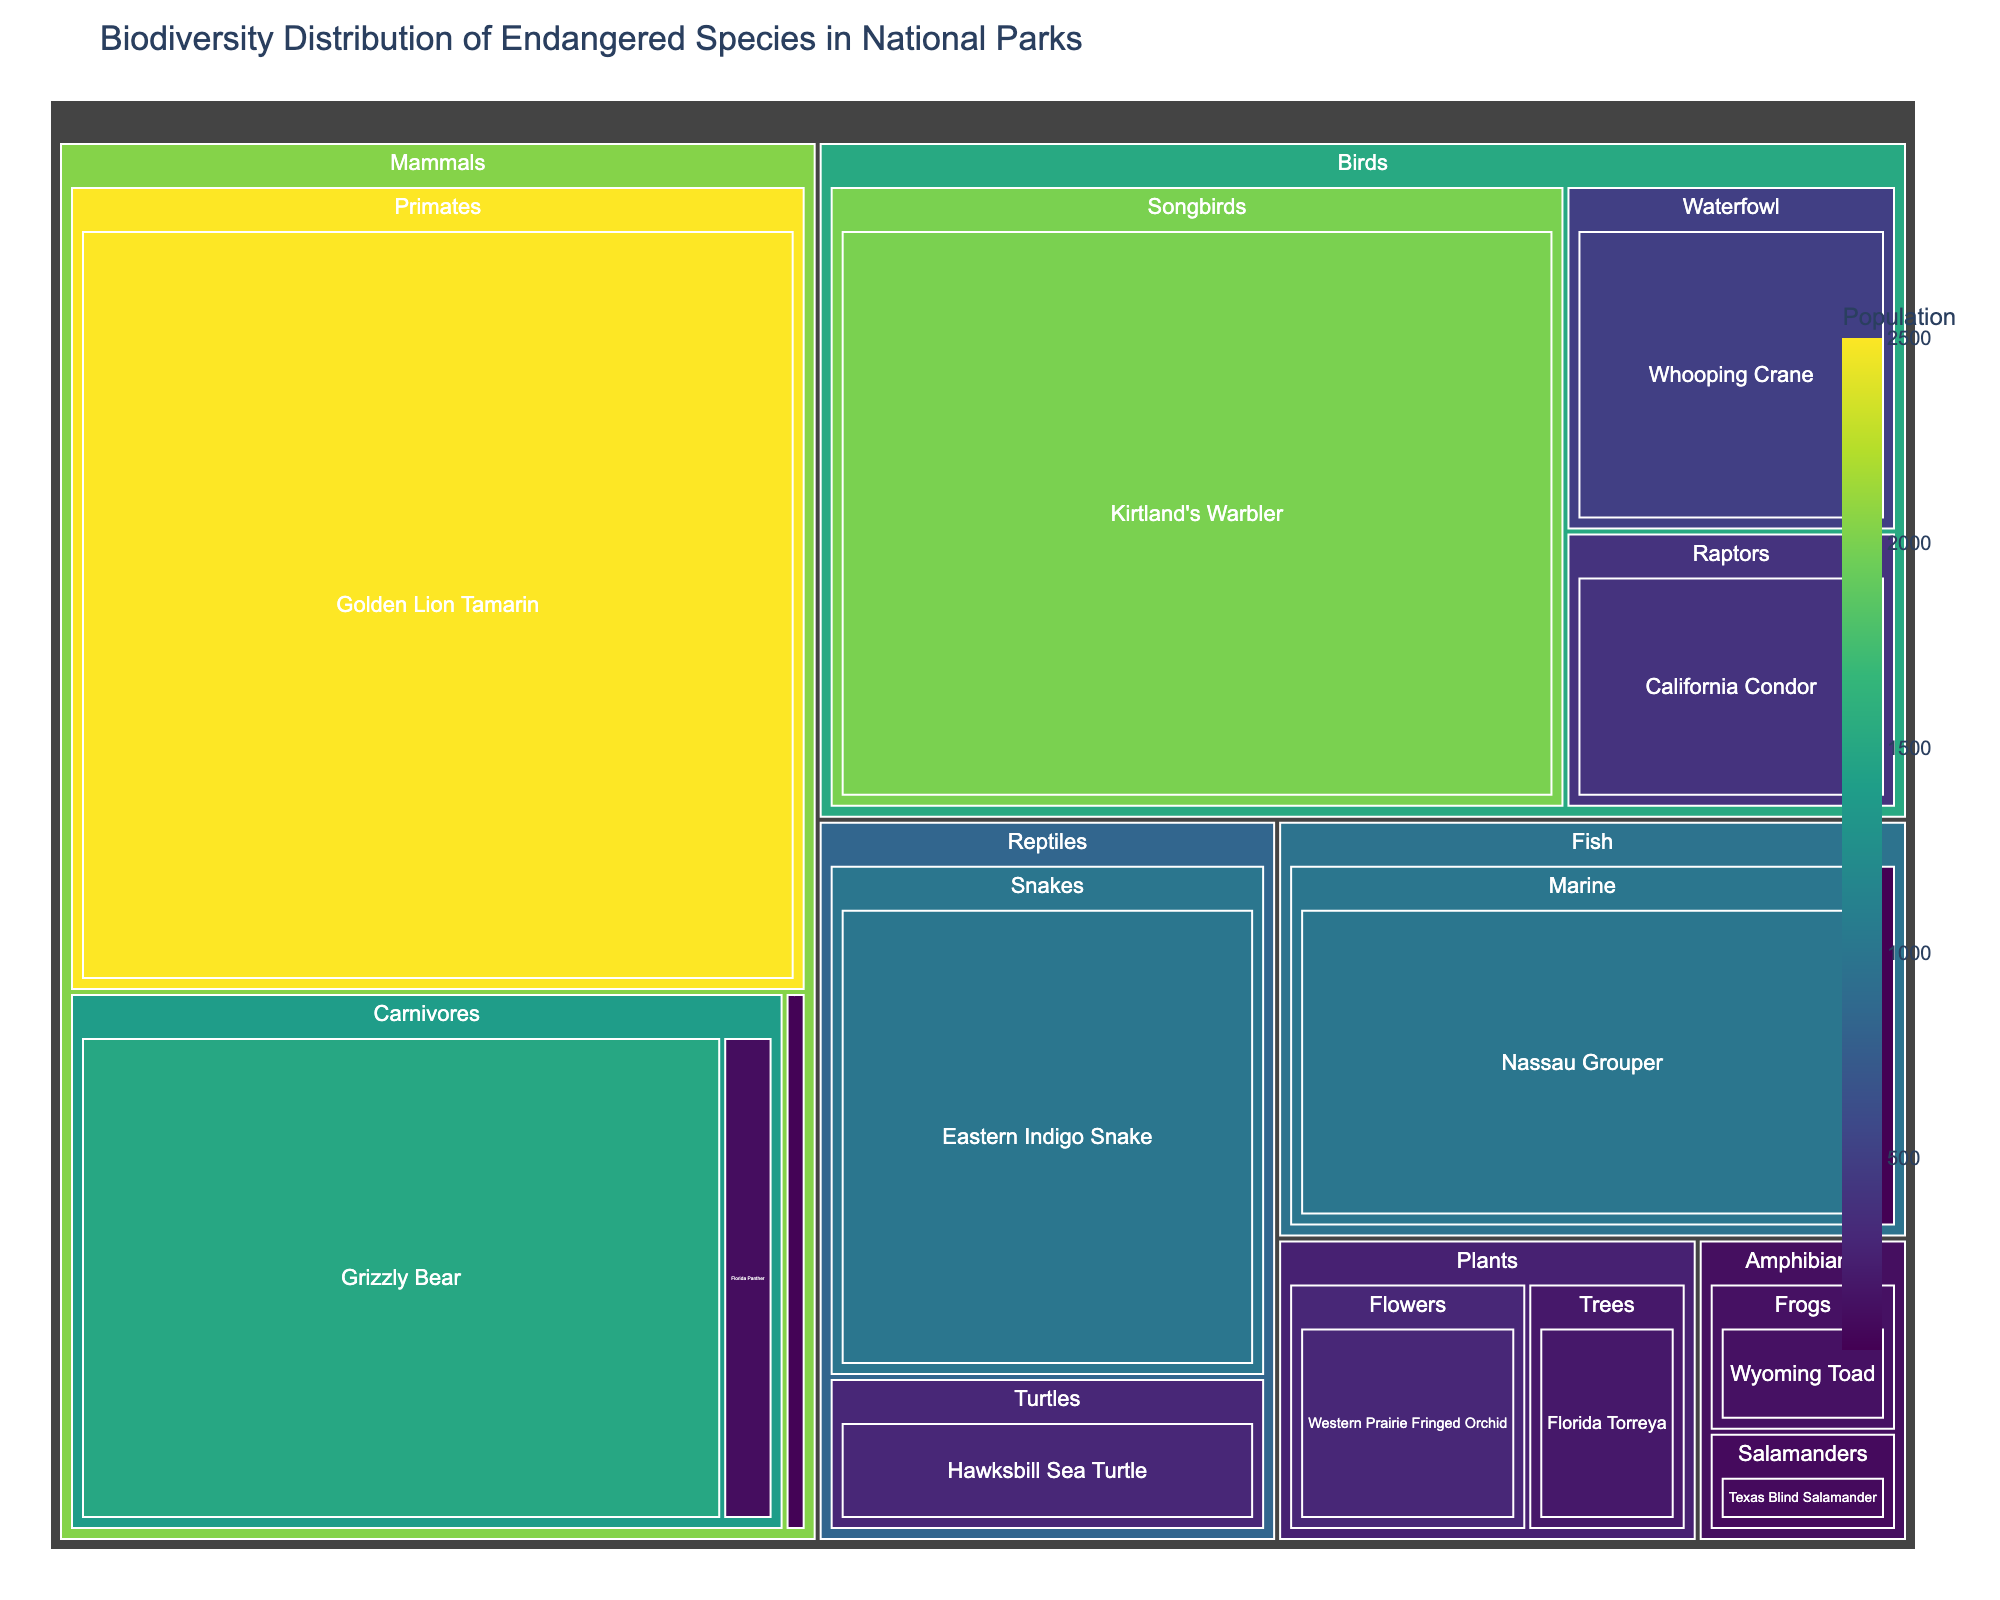What is the title of the treemap? The title of the treemap is usually located at the top of the figure and it provides a brief description of what the figure represents. It reads: 'Biodiversity Distribution of Endangered Species in National Parks’.
Answer: Biodiversity Distribution of Endangered Species in National Parks What taxonomic group of Mammals has the highest population? Within the treemap, look for the 'Mammals' category and observe which subgroup has the highest population value. The 'Primates' subgroup, specifically the 'Golden Lion Tamarin', has the highest population.
Answer: Primates How many categories of species are represented in the treemap? The categories of species are typically represented by the different colored sections at the top level of the treemap. Counting them, we see categories for Mammals, Birds, Reptiles, Amphibians, Fish, and Plants.
Answer: 6 Which species has the smallest population and what is that population? To find the species with the smallest population, identify the smallest rectangle within the treemap. The 'Devil's Hole Pupfish' in the Fish category has the smallest population.
Answer: Devil's Hole Pupfish, 35 What is the total population of all endangered species in the Amphibians category? Sum up the populations of all species within the Amphibians category: Wyoming Toad (150) and Texas Blind Salamander (100). 150 + 100 = 250
Answer: 250 Compare the population of the 'Hawksbill Sea Turtle' with the 'Florida Panther'. Which one is greater? Look at the population values represented by the size and labels of the rectangles for both species. The 'Hawksbill Sea Turtle' has a population of 300 while the 'Florida Panther' has 120, thus the Hawkbsill Sea Turtle has a greater population.
Answer: Hawksbill Sea Turtle What is the average population of species in the Birds category? List the populations of all species in the Birds category and calculate the average: California Condor (400), Whooping Crane (500), and Kirtland's Warbler (2000). (400 + 500 + 2000) / 3 = 2900 / 3 = approximately 967.
Answer: 967 Which taxonomic group within Reptiles has the highest population? Within the Reptiles category, compare the population values of the subgroups. 'Snakes', represented by the 'Eastern Indigo Snake' with a population of 1000, is the highest.
Answer: Snakes How does the population of the 'Woodland Caribou' compare to the 'Nassau Grouper'? Compare the population numbers directly. The 'Woodland Caribou' has a population of 50 while the 'Nassau Grouper' has 1000. The Nassau Grouper has a much larger population.
Answer: Nassau Grouper What is the combined population of all species in the Plants category? Add the populations of the species within the Plants category: Florida Torreya (200) and Western Prairie Fringed Orchid (300). 200 + 300 = 500
Answer: 500 